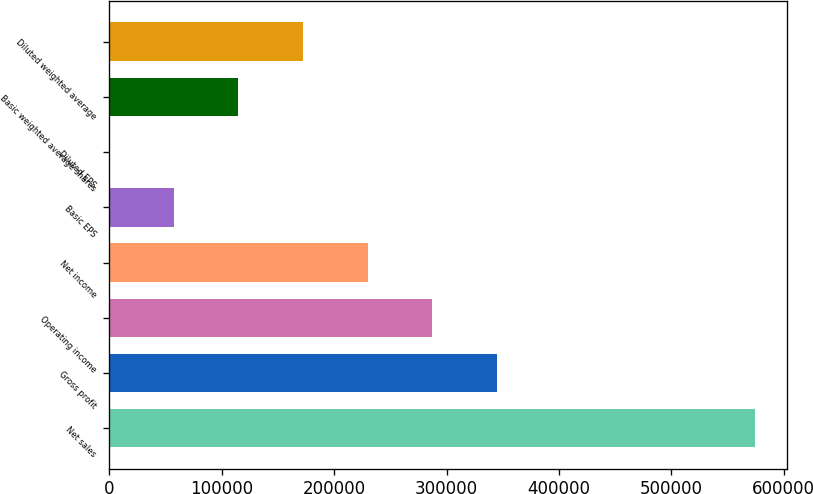<chart> <loc_0><loc_0><loc_500><loc_500><bar_chart><fcel>Net sales<fcel>Gross profit<fcel>Operating income<fcel>Net income<fcel>Basic EPS<fcel>Diluted EPS<fcel>Basic weighted average shares<fcel>Diluted weighted average<nl><fcel>574490<fcel>344694<fcel>287246<fcel>229797<fcel>57450<fcel>1.08<fcel>114899<fcel>172348<nl></chart> 